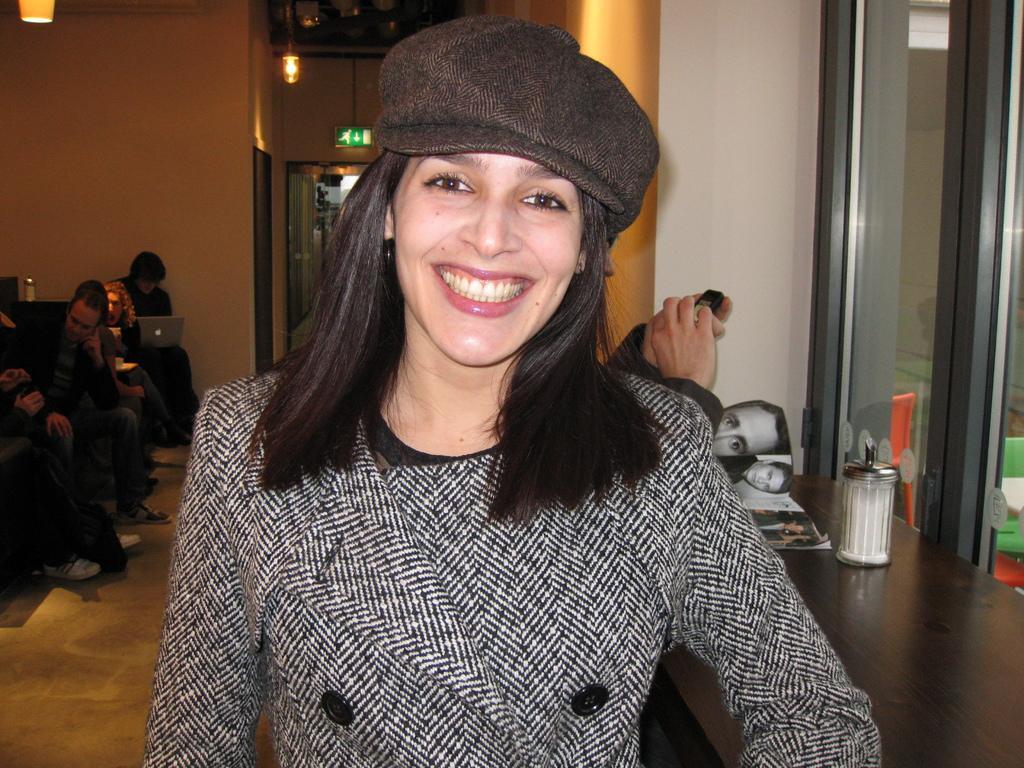In one or two sentences, can you explain what this image depicts? In this picture we can see a woman wore a cap and smiling. In the background we can see some people, walls, lights, laptop, jars, book, window, direction board and some objects. 